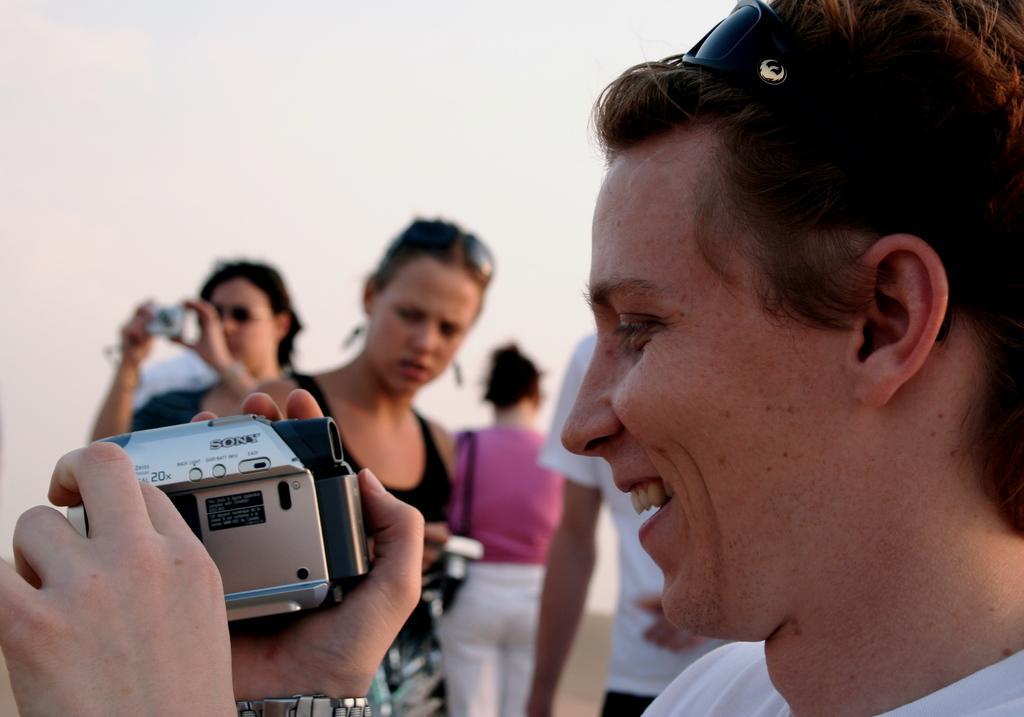Please provide a concise description of this image. In this picture we can see woman holding camera in her hand and smiling and in background we can see some more persons holding cameras. 